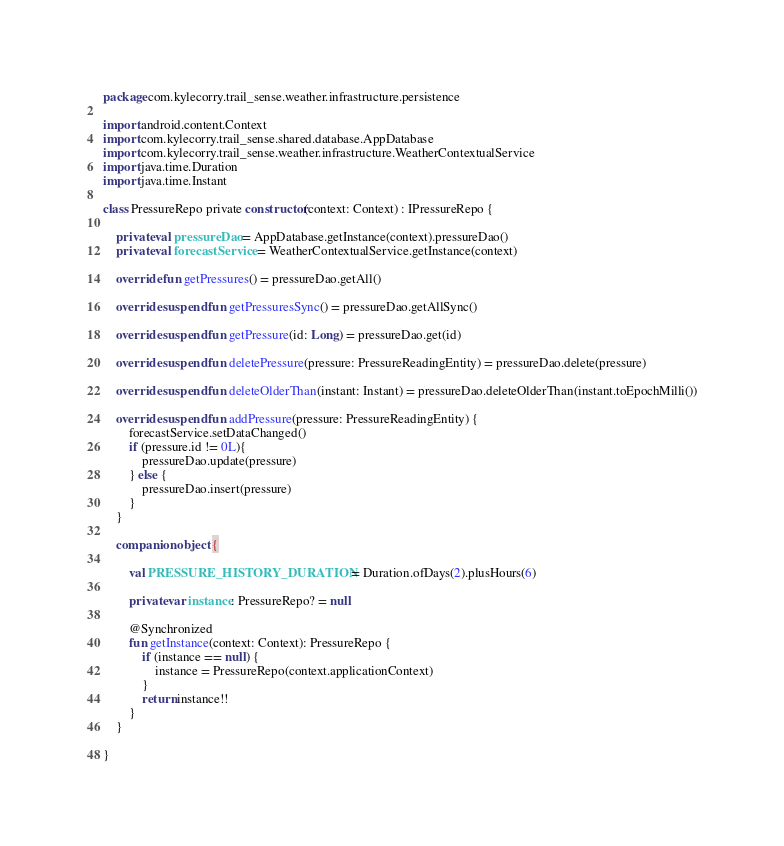<code> <loc_0><loc_0><loc_500><loc_500><_Kotlin_>package com.kylecorry.trail_sense.weather.infrastructure.persistence

import android.content.Context
import com.kylecorry.trail_sense.shared.database.AppDatabase
import com.kylecorry.trail_sense.weather.infrastructure.WeatherContextualService
import java.time.Duration
import java.time.Instant

class PressureRepo private constructor(context: Context) : IPressureRepo {

    private val pressureDao = AppDatabase.getInstance(context).pressureDao()
    private val forecastService = WeatherContextualService.getInstance(context)

    override fun getPressures() = pressureDao.getAll()

    override suspend fun getPressuresSync() = pressureDao.getAllSync()

    override suspend fun getPressure(id: Long) = pressureDao.get(id)

    override suspend fun deletePressure(pressure: PressureReadingEntity) = pressureDao.delete(pressure)

    override suspend fun deleteOlderThan(instant: Instant) = pressureDao.deleteOlderThan(instant.toEpochMilli())

    override suspend fun addPressure(pressure: PressureReadingEntity) {
        forecastService.setDataChanged()
        if (pressure.id != 0L){
            pressureDao.update(pressure)
        } else {
            pressureDao.insert(pressure)
        }
    }

    companion object {

        val PRESSURE_HISTORY_DURATION = Duration.ofDays(2).plusHours(6)

        private var instance: PressureRepo? = null

        @Synchronized
        fun getInstance(context: Context): PressureRepo {
            if (instance == null) {
                instance = PressureRepo(context.applicationContext)
            }
            return instance!!
        }
    }

}</code> 